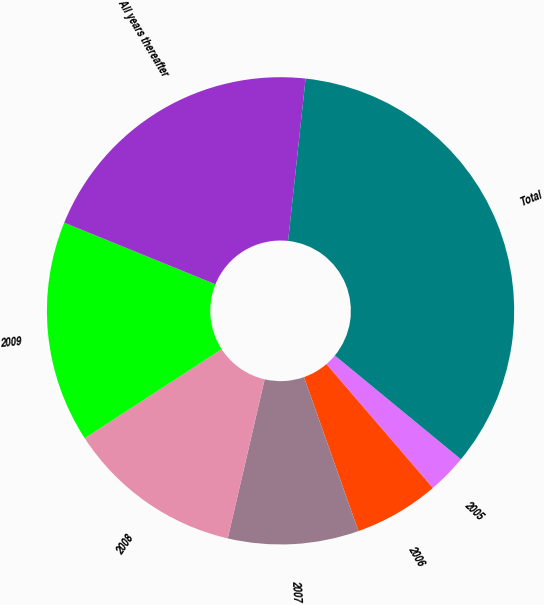Convert chart. <chart><loc_0><loc_0><loc_500><loc_500><pie_chart><fcel>2005<fcel>2006<fcel>2007<fcel>2008<fcel>2009<fcel>All years thereafter<fcel>Total<nl><fcel>2.74%<fcel>5.89%<fcel>9.04%<fcel>12.19%<fcel>15.34%<fcel>20.55%<fcel>34.25%<nl></chart> 